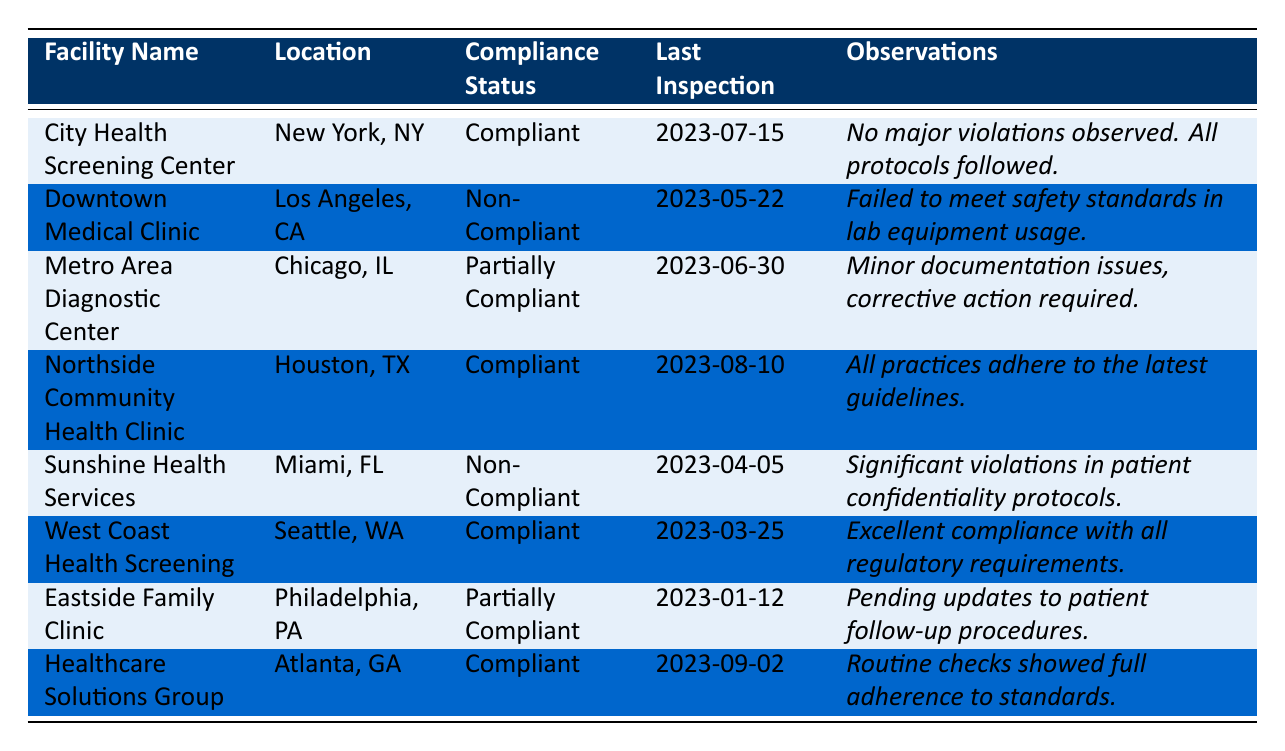What is the compliance status of the City Health Screening Center? The table lists the City Health Screening Center with a compliance status of "Compliant."
Answer: Compliant When was the last inspection of the Sunshine Health Services? The table shows that the last inspection date for Sunshine Health Services was "2023-04-05."
Answer: 2023-04-05 How many facilities are compliant? The table indicates three facilities are compliant: City Health Screening Center, Northside Community Health Clinic, and West Coast Health Screening.
Answer: 3 What are the observations for the Metro Area Diagnostic Center? According to the table, the observations for the Metro Area Diagnostic Center are "Minor documentation issues, corrective action required."
Answer: Minor documentation issues, corrective action required Is the Downtown Medical Clinic compliant? The table states that the Downtown Medical Clinic is "Non-Compliant."
Answer: No Which facility had the last inspection date in August 2023? The table shows that Northside Community Health Clinic had its last inspection on "2023-08-10."
Answer: Northside Community Health Clinic How many facilities are non-compliant? From the table, there are two non-compliant facilities: Downtown Medical Clinic and Sunshine Health Services.
Answer: 2 What specific violations were observed at the Sunshine Health Services? The table indicates that there were "Significant violations in patient confidentiality protocols" at Sunshine Health Services.
Answer: Significant violations in patient confidentiality protocols If Eastside Family Clinic updates its patient follow-up procedures, will it be compliant? The table notes that Eastside Family Clinic is currently "Partially Compliant" and is pending updates to patient follow-up procedures, so if the updates are made, its status could change to compliant.
Answer: Yes, if updates are made Which facility has the earliest inspection date listed in the table? The earliest inspection date in the table is for Eastside Family Clinic on "2023-01-12."
Answer: Eastside Family Clinic How does the compliance status of facilities in Los Angeles compare to those in New York? In the table, the facility in Los Angeles (Downtown Medical Clinic) is "Non-Compliant," while the facility in New York (City Health Screening Center) is "Compliant."
Answer: Los Angeles is non-compliant, New York is compliant 